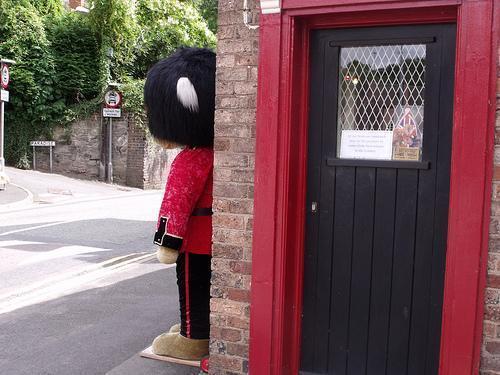How many guards?
Give a very brief answer. 1. 